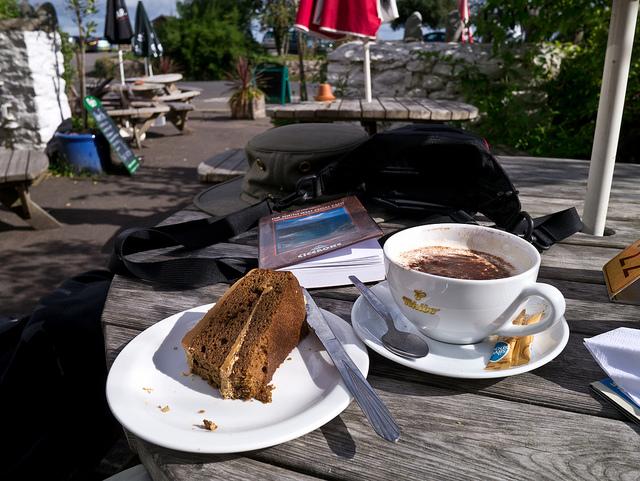Is there a travel guide on the table?
Write a very short answer. Yes. What color plate is this?
Write a very short answer. White. What type of silverware is on the plates?
Keep it brief. Knife and spoon. 